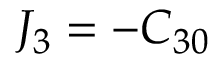Convert formula to latex. <formula><loc_0><loc_0><loc_500><loc_500>J _ { 3 } = - C _ { 3 0 }</formula> 